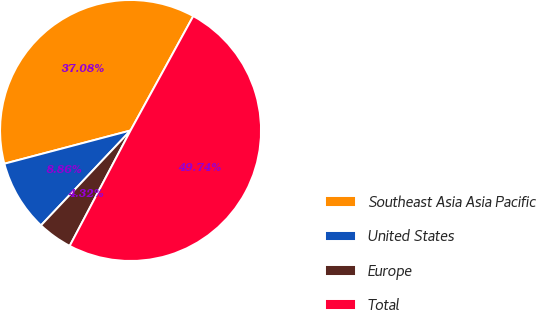Convert chart. <chart><loc_0><loc_0><loc_500><loc_500><pie_chart><fcel>Southeast Asia Asia Pacific<fcel>United States<fcel>Europe<fcel>Total<nl><fcel>37.08%<fcel>8.86%<fcel>4.32%<fcel>49.74%<nl></chart> 